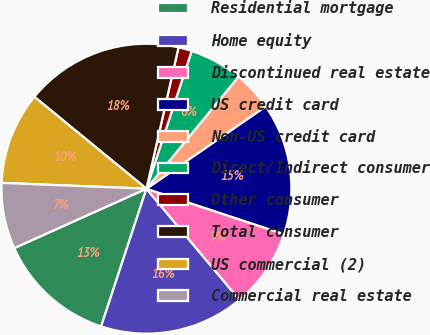<chart> <loc_0><loc_0><loc_500><loc_500><pie_chart><fcel>Residential mortgage<fcel>Home equity<fcel>Discontinued real estate<fcel>US credit card<fcel>Non-US credit card<fcel>Direct/Indirect consumer<fcel>Other consumer<fcel>Total consumer<fcel>US commercial (2)<fcel>Commercial real estate<nl><fcel>13.22%<fcel>16.15%<fcel>8.83%<fcel>14.69%<fcel>4.43%<fcel>5.9%<fcel>1.5%<fcel>17.62%<fcel>10.29%<fcel>7.36%<nl></chart> 